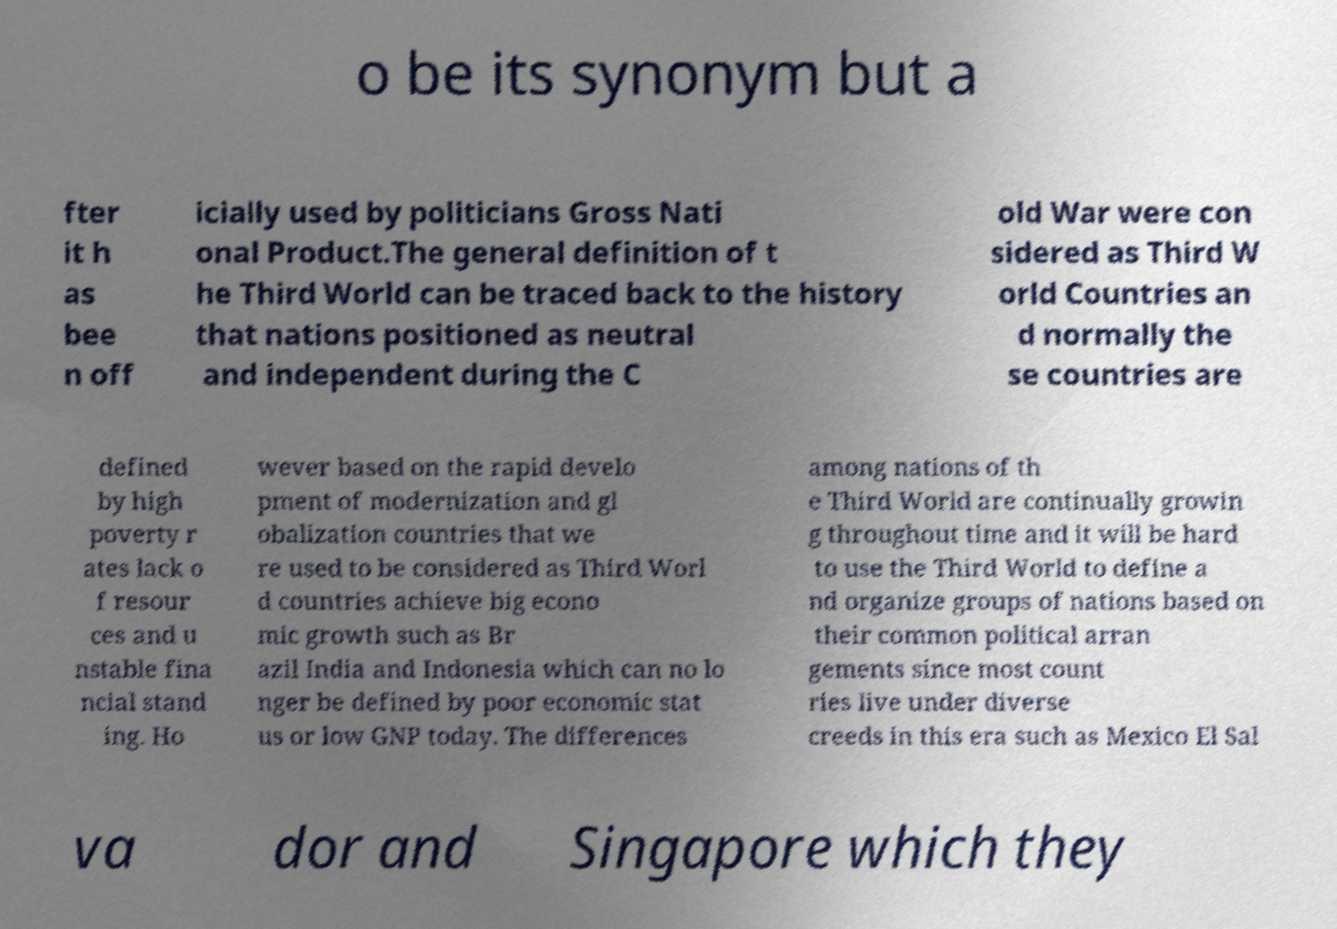What messages or text are displayed in this image? I need them in a readable, typed format. o be its synonym but a fter it h as bee n off icially used by politicians Gross Nati onal Product.The general definition of t he Third World can be traced back to the history that nations positioned as neutral and independent during the C old War were con sidered as Third W orld Countries an d normally the se countries are defined by high poverty r ates lack o f resour ces and u nstable fina ncial stand ing. Ho wever based on the rapid develo pment of modernization and gl obalization countries that we re used to be considered as Third Worl d countries achieve big econo mic growth such as Br azil India and Indonesia which can no lo nger be defined by poor economic stat us or low GNP today. The differences among nations of th e Third World are continually growin g throughout time and it will be hard to use the Third World to define a nd organize groups of nations based on their common political arran gements since most count ries live under diverse creeds in this era such as Mexico El Sal va dor and Singapore which they 